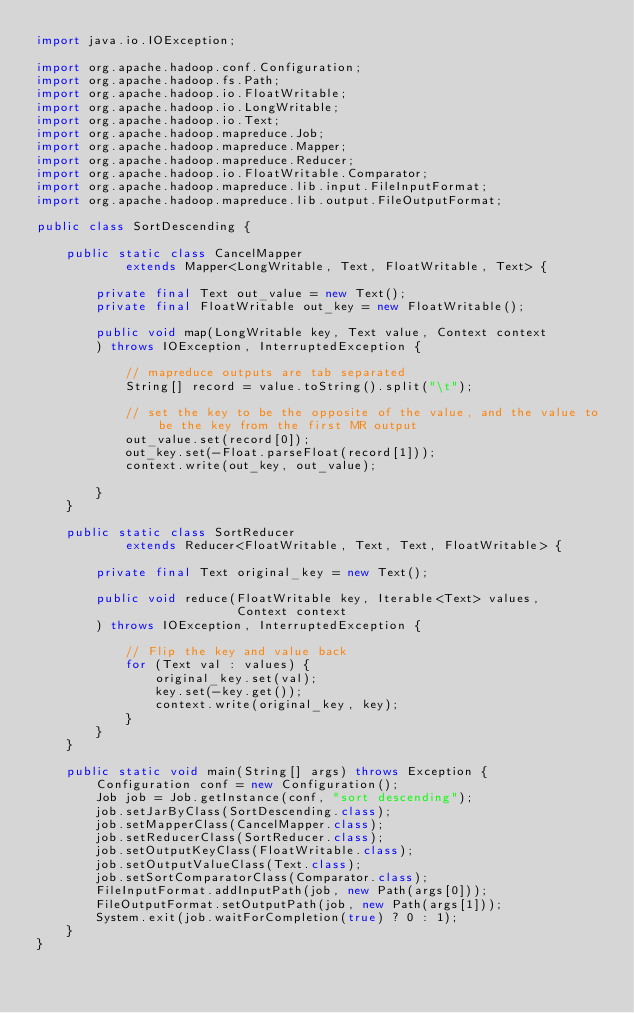Convert code to text. <code><loc_0><loc_0><loc_500><loc_500><_Java_>import java.io.IOException;

import org.apache.hadoop.conf.Configuration;
import org.apache.hadoop.fs.Path;
import org.apache.hadoop.io.FloatWritable;
import org.apache.hadoop.io.LongWritable;
import org.apache.hadoop.io.Text;
import org.apache.hadoop.mapreduce.Job;
import org.apache.hadoop.mapreduce.Mapper;
import org.apache.hadoop.mapreduce.Reducer;
import org.apache.hadoop.io.FloatWritable.Comparator;
import org.apache.hadoop.mapreduce.lib.input.FileInputFormat;
import org.apache.hadoop.mapreduce.lib.output.FileOutputFormat;

public class SortDescending {

    public static class CancelMapper
            extends Mapper<LongWritable, Text, FloatWritable, Text> {

        private final Text out_value = new Text();
        private final FloatWritable out_key = new FloatWritable();

        public void map(LongWritable key, Text value, Context context
        ) throws IOException, InterruptedException {

            // mapreduce outputs are tab separated
            String[] record = value.toString().split("\t");

            // set the key to be the opposite of the value, and the value to be the key from the first MR output
            out_value.set(record[0]);
            out_key.set(-Float.parseFloat(record[1]));
            context.write(out_key, out_value);

        }
    }

    public static class SortReducer
            extends Reducer<FloatWritable, Text, Text, FloatWritable> {

        private final Text original_key = new Text();

        public void reduce(FloatWritable key, Iterable<Text> values,
                           Context context
        ) throws IOException, InterruptedException {

            // Flip the key and value back
            for (Text val : values) {
                original_key.set(val);
                key.set(-key.get());
                context.write(original_key, key);
            }
        }
    }

    public static void main(String[] args) throws Exception {
        Configuration conf = new Configuration();
        Job job = Job.getInstance(conf, "sort descending");
        job.setJarByClass(SortDescending.class);
        job.setMapperClass(CancelMapper.class);
        job.setReducerClass(SortReducer.class);
        job.setOutputKeyClass(FloatWritable.class);
        job.setOutputValueClass(Text.class);
        job.setSortComparatorClass(Comparator.class);
        FileInputFormat.addInputPath(job, new Path(args[0]));
        FileOutputFormat.setOutputPath(job, new Path(args[1]));
        System.exit(job.waitForCompletion(true) ? 0 : 1);
    }
}
</code> 